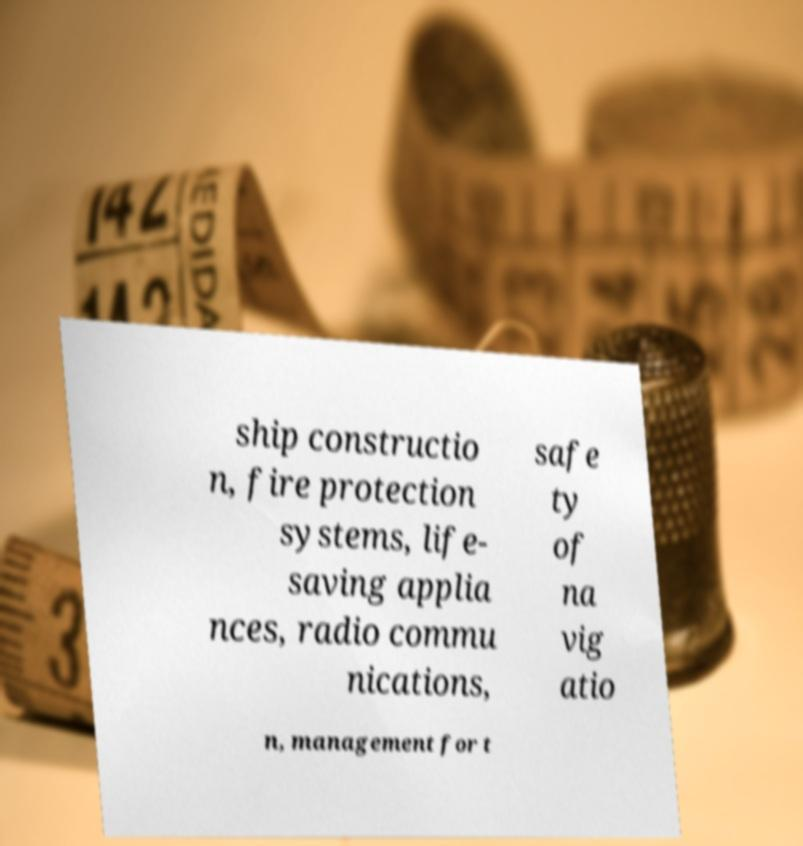Can you accurately transcribe the text from the provided image for me? ship constructio n, fire protection systems, life- saving applia nces, radio commu nications, safe ty of na vig atio n, management for t 